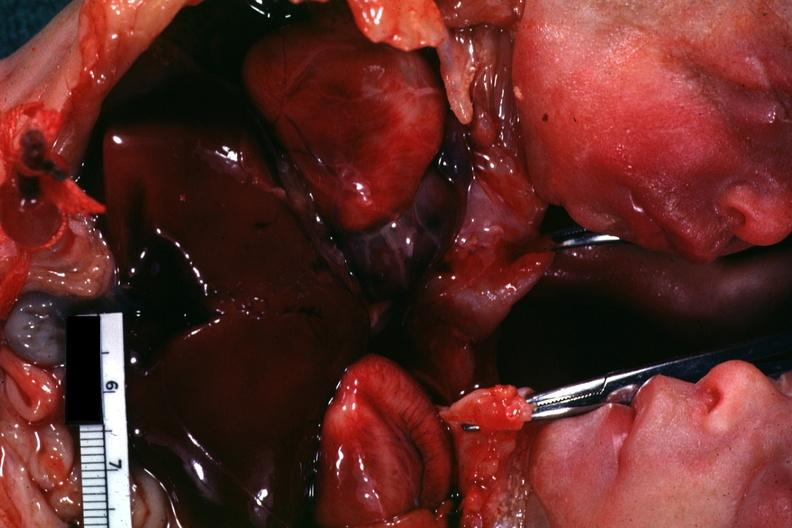does chest and abdomen slide show opened chest with two hearts?
Answer the question using a single word or phrase. Yes 